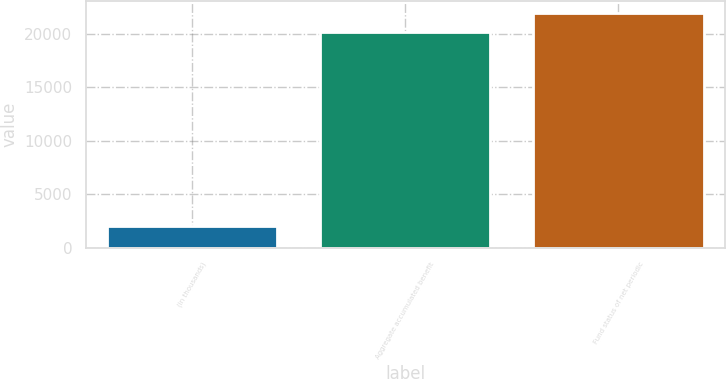Convert chart to OTSL. <chart><loc_0><loc_0><loc_500><loc_500><bar_chart><fcel>(in thousands)<fcel>Aggregate accumulated benefit<fcel>Fund status of net periodic<nl><fcel>2002<fcel>20141<fcel>21954.9<nl></chart> 